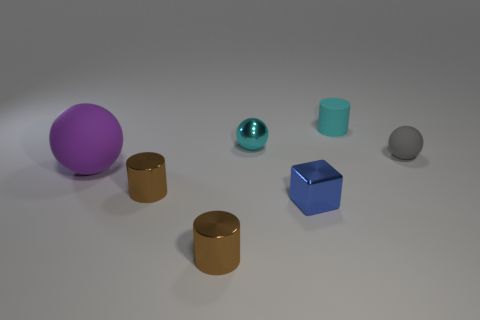Subtract all shiny cylinders. How many cylinders are left? 1 Subtract all brown balls. How many brown cylinders are left? 2 Add 1 cyan cylinders. How many objects exist? 8 Subtract 1 cylinders. How many cylinders are left? 2 Subtract all blocks. How many objects are left? 6 Add 6 purple spheres. How many purple spheres are left? 7 Add 6 small brown shiny spheres. How many small brown shiny spheres exist? 6 Subtract 1 cyan spheres. How many objects are left? 6 Subtract all cyan blocks. Subtract all red cylinders. How many blocks are left? 1 Subtract all tiny red matte objects. Subtract all cylinders. How many objects are left? 4 